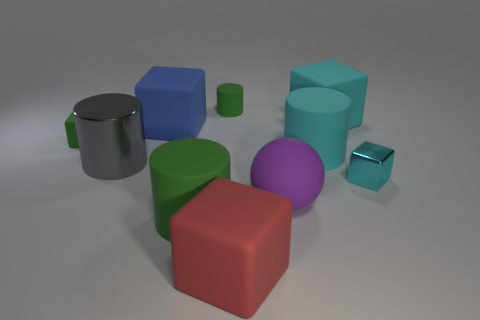Do the tiny green cylinder and the tiny cyan thing have the same material?
Your response must be concise. No. There is a tiny cyan object that is the same shape as the large red object; what material is it?
Ensure brevity in your answer.  Metal. Are there fewer green matte objects that are in front of the big gray cylinder than cyan cubes?
Your answer should be very brief. Yes. What number of small green matte cubes are behind the large green cylinder?
Keep it short and to the point. 1. Does the small object that is on the left side of the big blue matte cube have the same shape as the big red thing that is in front of the big blue matte cube?
Provide a succinct answer. Yes. What is the shape of the big rubber thing that is both right of the big green cylinder and in front of the big purple matte object?
Give a very brief answer. Cube. There is a cyan cylinder that is made of the same material as the purple thing; what size is it?
Ensure brevity in your answer.  Large. Is the number of green blocks less than the number of large yellow matte cylinders?
Ensure brevity in your answer.  No. The small thing on the right side of the big rubber sphere on the right side of the blue cube behind the big green cylinder is made of what material?
Provide a short and direct response. Metal. Is the material of the green thing on the left side of the blue block the same as the green cylinder in front of the small cyan shiny object?
Offer a terse response. Yes. 